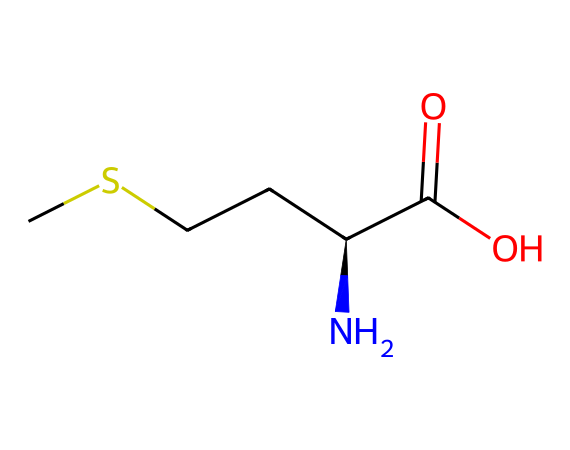How many carbon atoms are in methionine? The SMILES representation shows "CSCC" and "[C@H]", which indicate four carbon atoms in total.
Answer: four What is the functional group present in methionine? The chemical structure shows a carboxylic acid group, indicated by "C(=O)O".
Answer: carboxylic acid Which atom in methionine is responsible for its sulfur content? The "S" in the SMILES representation "CSCC" indicates the presence of a sulfur atom.
Answer: sulfur What type of amino acid is methionine? Methionine contains a sulfur atom and is classified as an essential amino acid.
Answer: essential How many nitrogen atoms are present in methionine? In the SMILES string, the presence of "N" shows that there is one nitrogen atom in the structure.
Answer: one What characterizes methionine as a sulfur-containing amino acid? The presence of a sulfur atom in its side chain, as indicated by "CS", is what qualifies methionine as a sulfur-containing amino acid.
Answer: sulfur atom How does the presence of sulfur in methionine affect protein structure? Sulfur can form disulfide bonds with other sulfur-containing amino acids like cysteine, contributing to the stability of protein structures.
Answer: stabilizes protein structures 